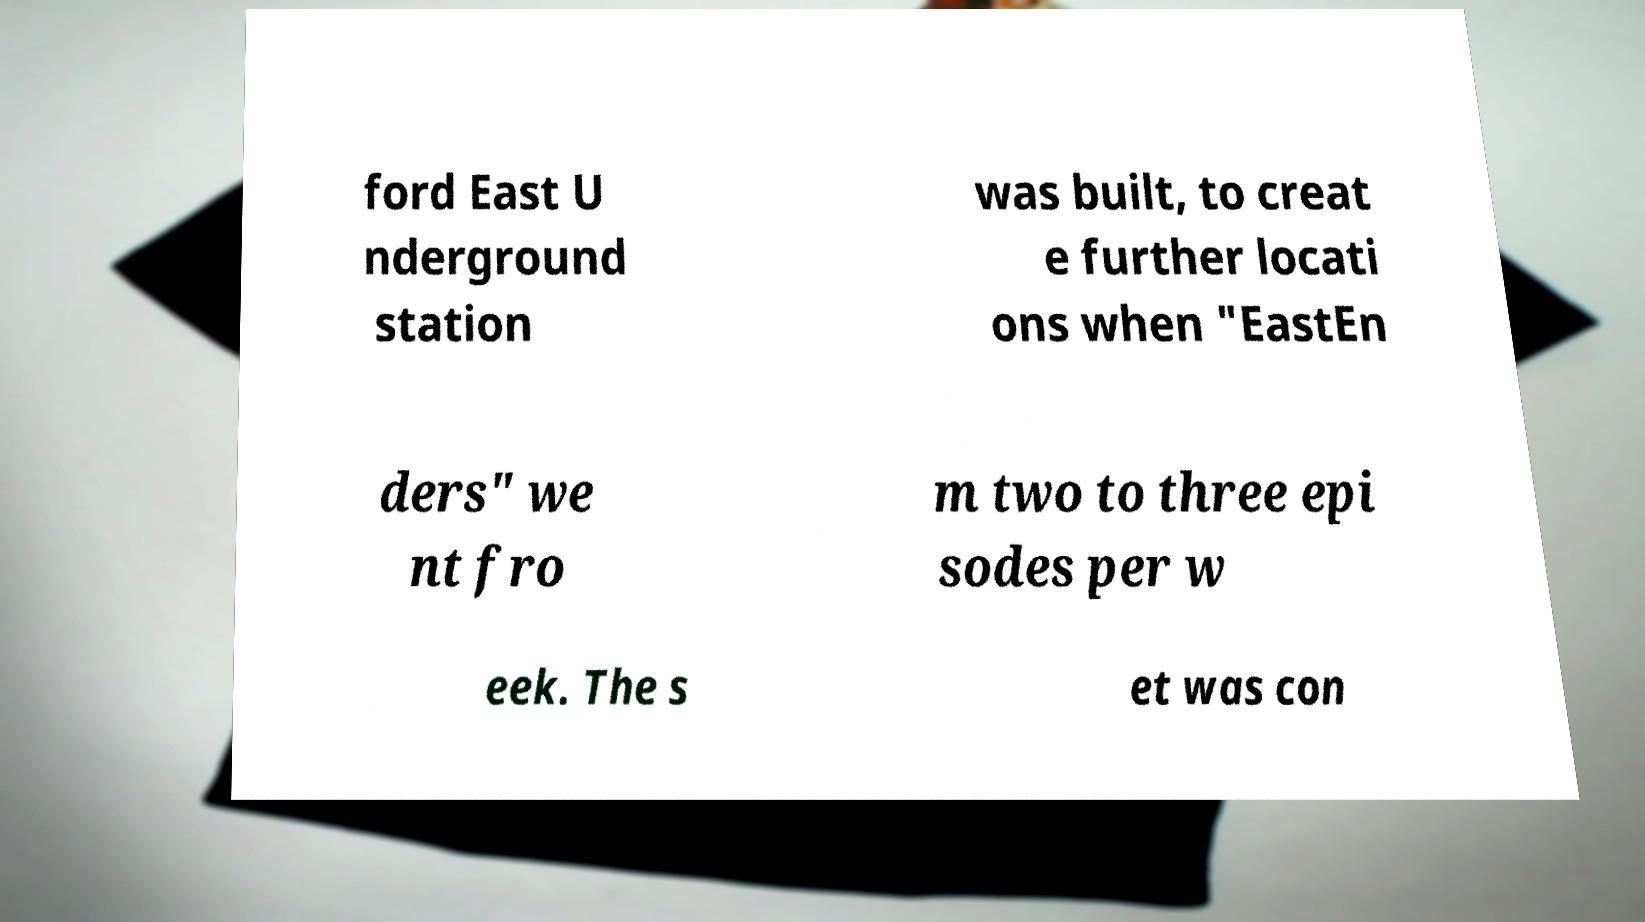Could you extract and type out the text from this image? ford East U nderground station was built, to creat e further locati ons when "EastEn ders" we nt fro m two to three epi sodes per w eek. The s et was con 